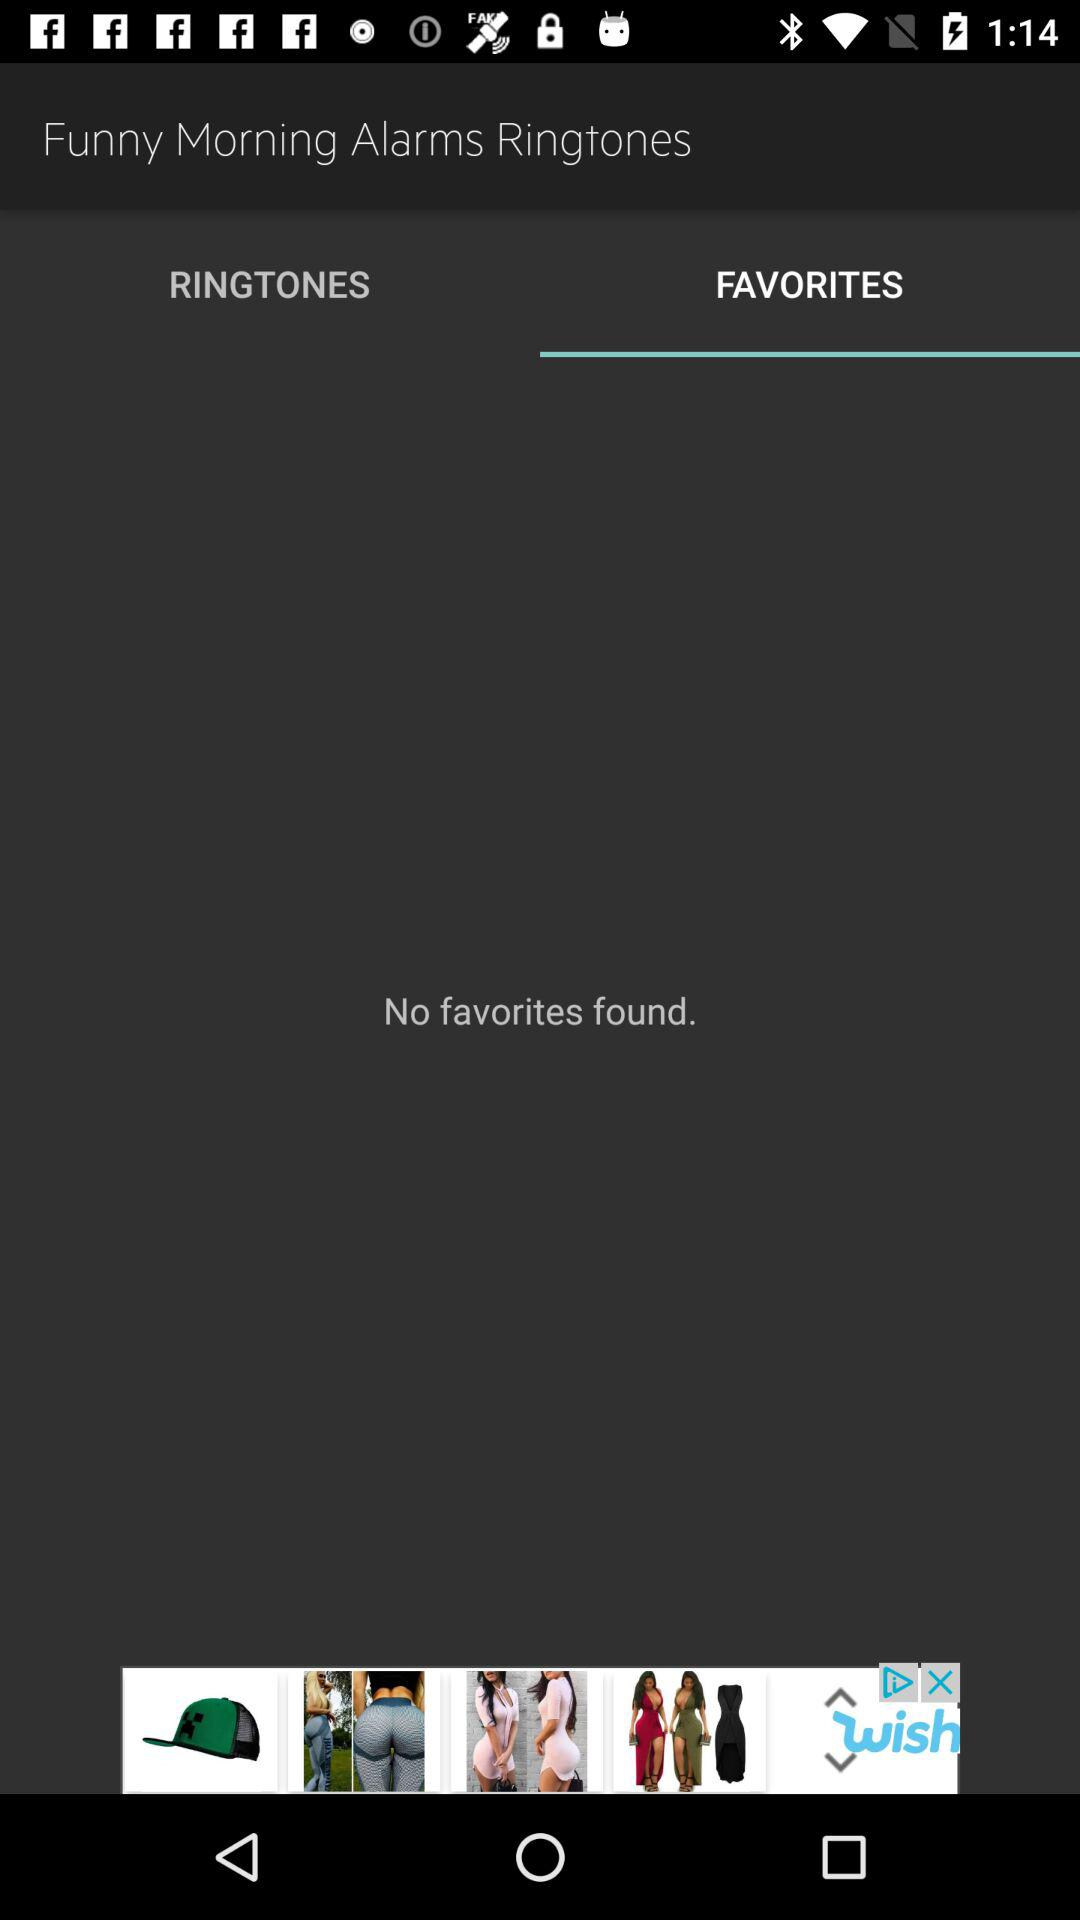Are there any favorites? There are no favorites. 